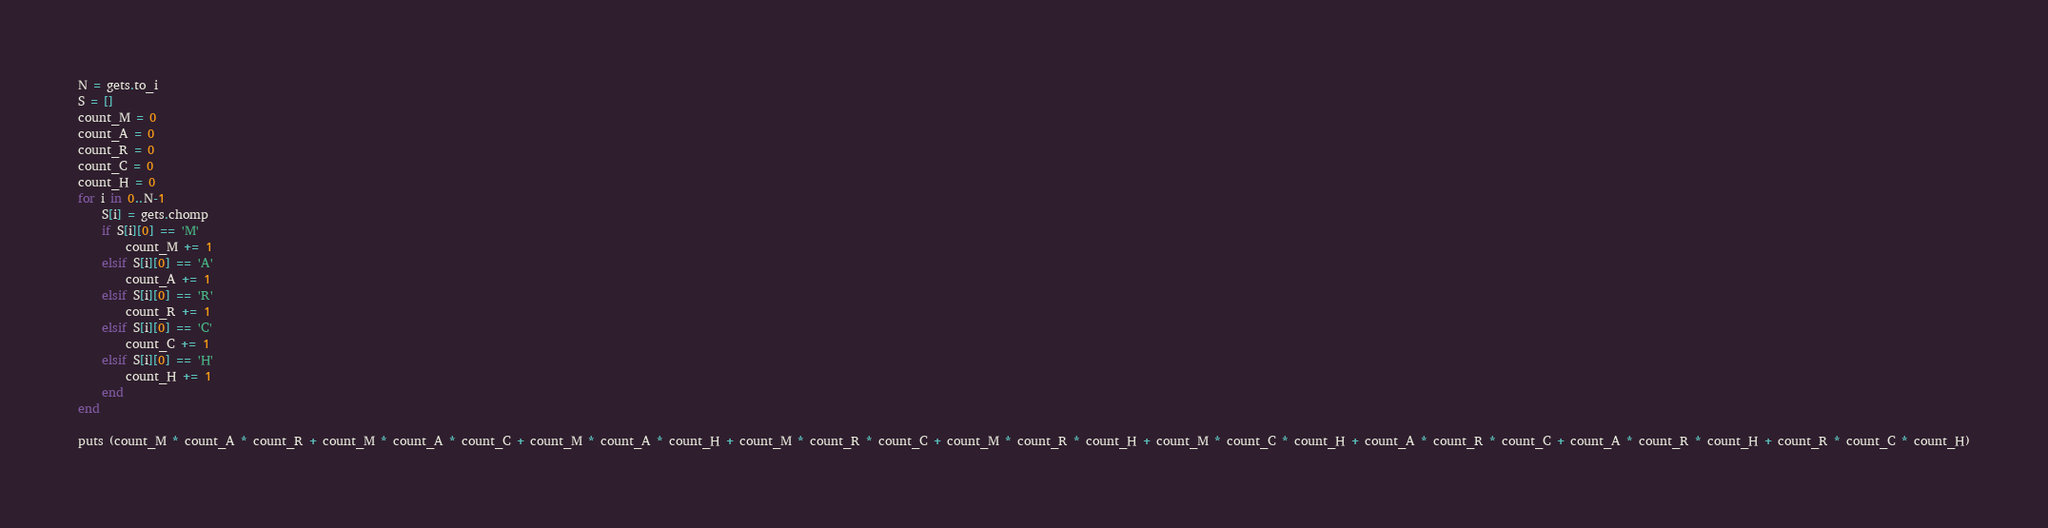Convert code to text. <code><loc_0><loc_0><loc_500><loc_500><_Ruby_>N = gets.to_i
S = []
count_M = 0
count_A = 0
count_R = 0
count_C = 0
count_H = 0
for i in 0..N-1
    S[i] = gets.chomp
    if S[i][0] == 'M'
        count_M += 1
    elsif S[i][0] == 'A'
        count_A += 1
    elsif S[i][0] == 'R'
        count_R += 1
    elsif S[i][0] == 'C'
        count_C += 1
    elsif S[i][0] == 'H'
        count_H += 1
    end
end

puts (count_M * count_A * count_R + count_M * count_A * count_C + count_M * count_A * count_H + count_M * count_R * count_C + count_M * count_R * count_H + count_M * count_C * count_H + count_A * count_R * count_C + count_A * count_R * count_H + count_R * count_C * count_H)</code> 